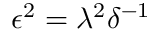Convert formula to latex. <formula><loc_0><loc_0><loc_500><loc_500>\epsilon ^ { 2 } = \lambda ^ { 2 } \delta ^ { - 1 }</formula> 